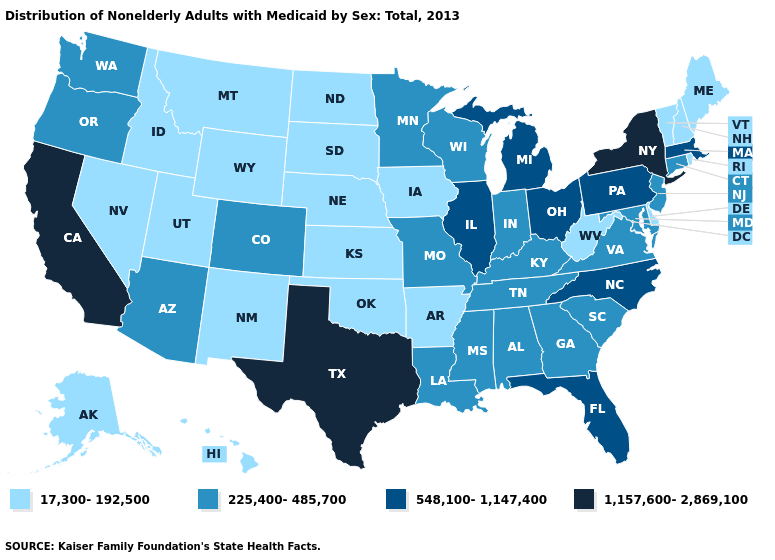Name the states that have a value in the range 225,400-485,700?
Concise answer only. Alabama, Arizona, Colorado, Connecticut, Georgia, Indiana, Kentucky, Louisiana, Maryland, Minnesota, Mississippi, Missouri, New Jersey, Oregon, South Carolina, Tennessee, Virginia, Washington, Wisconsin. Does Arkansas have the same value as Wisconsin?
Give a very brief answer. No. Does Delaware have a lower value than Montana?
Be succinct. No. Does the first symbol in the legend represent the smallest category?
Give a very brief answer. Yes. What is the value of Vermont?
Give a very brief answer. 17,300-192,500. What is the value of Texas?
Be succinct. 1,157,600-2,869,100. Does Ohio have a higher value than New York?
Answer briefly. No. What is the value of Ohio?
Short answer required. 548,100-1,147,400. Among the states that border West Virginia , does Pennsylvania have the highest value?
Concise answer only. Yes. What is the highest value in the Northeast ?
Concise answer only. 1,157,600-2,869,100. What is the value of Kentucky?
Be succinct. 225,400-485,700. Name the states that have a value in the range 225,400-485,700?
Concise answer only. Alabama, Arizona, Colorado, Connecticut, Georgia, Indiana, Kentucky, Louisiana, Maryland, Minnesota, Mississippi, Missouri, New Jersey, Oregon, South Carolina, Tennessee, Virginia, Washington, Wisconsin. What is the value of Pennsylvania?
Answer briefly. 548,100-1,147,400. Name the states that have a value in the range 17,300-192,500?
Keep it brief. Alaska, Arkansas, Delaware, Hawaii, Idaho, Iowa, Kansas, Maine, Montana, Nebraska, Nevada, New Hampshire, New Mexico, North Dakota, Oklahoma, Rhode Island, South Dakota, Utah, Vermont, West Virginia, Wyoming. Name the states that have a value in the range 225,400-485,700?
Answer briefly. Alabama, Arizona, Colorado, Connecticut, Georgia, Indiana, Kentucky, Louisiana, Maryland, Minnesota, Mississippi, Missouri, New Jersey, Oregon, South Carolina, Tennessee, Virginia, Washington, Wisconsin. 